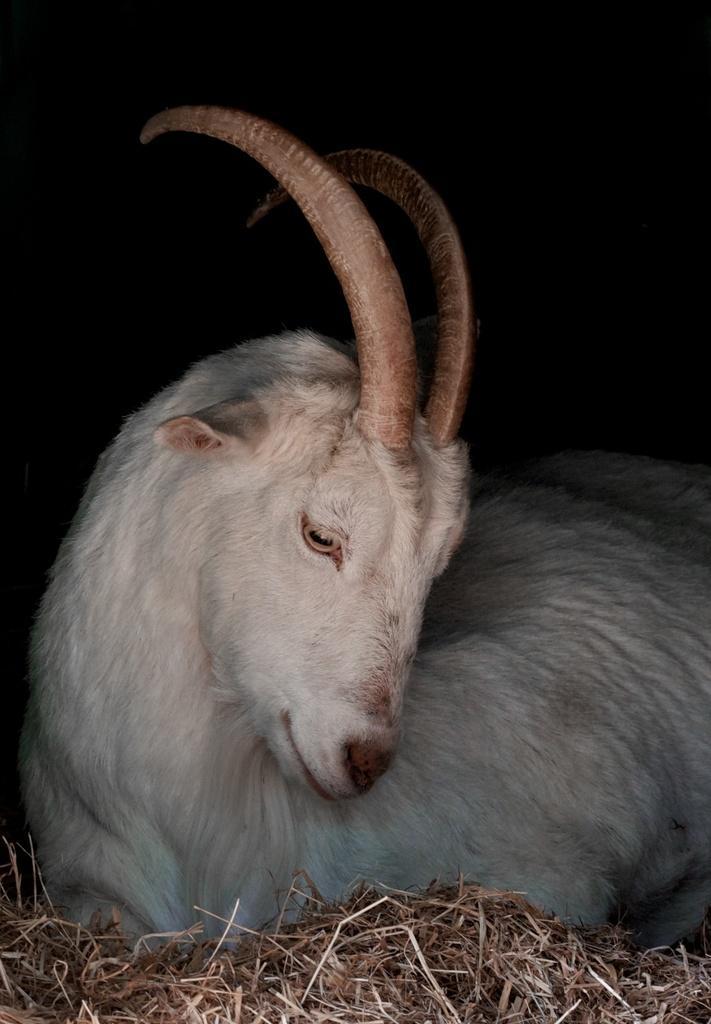Can you describe this image briefly? In the image there is a goat with horns is sitting on the grass. And there is a black background. 